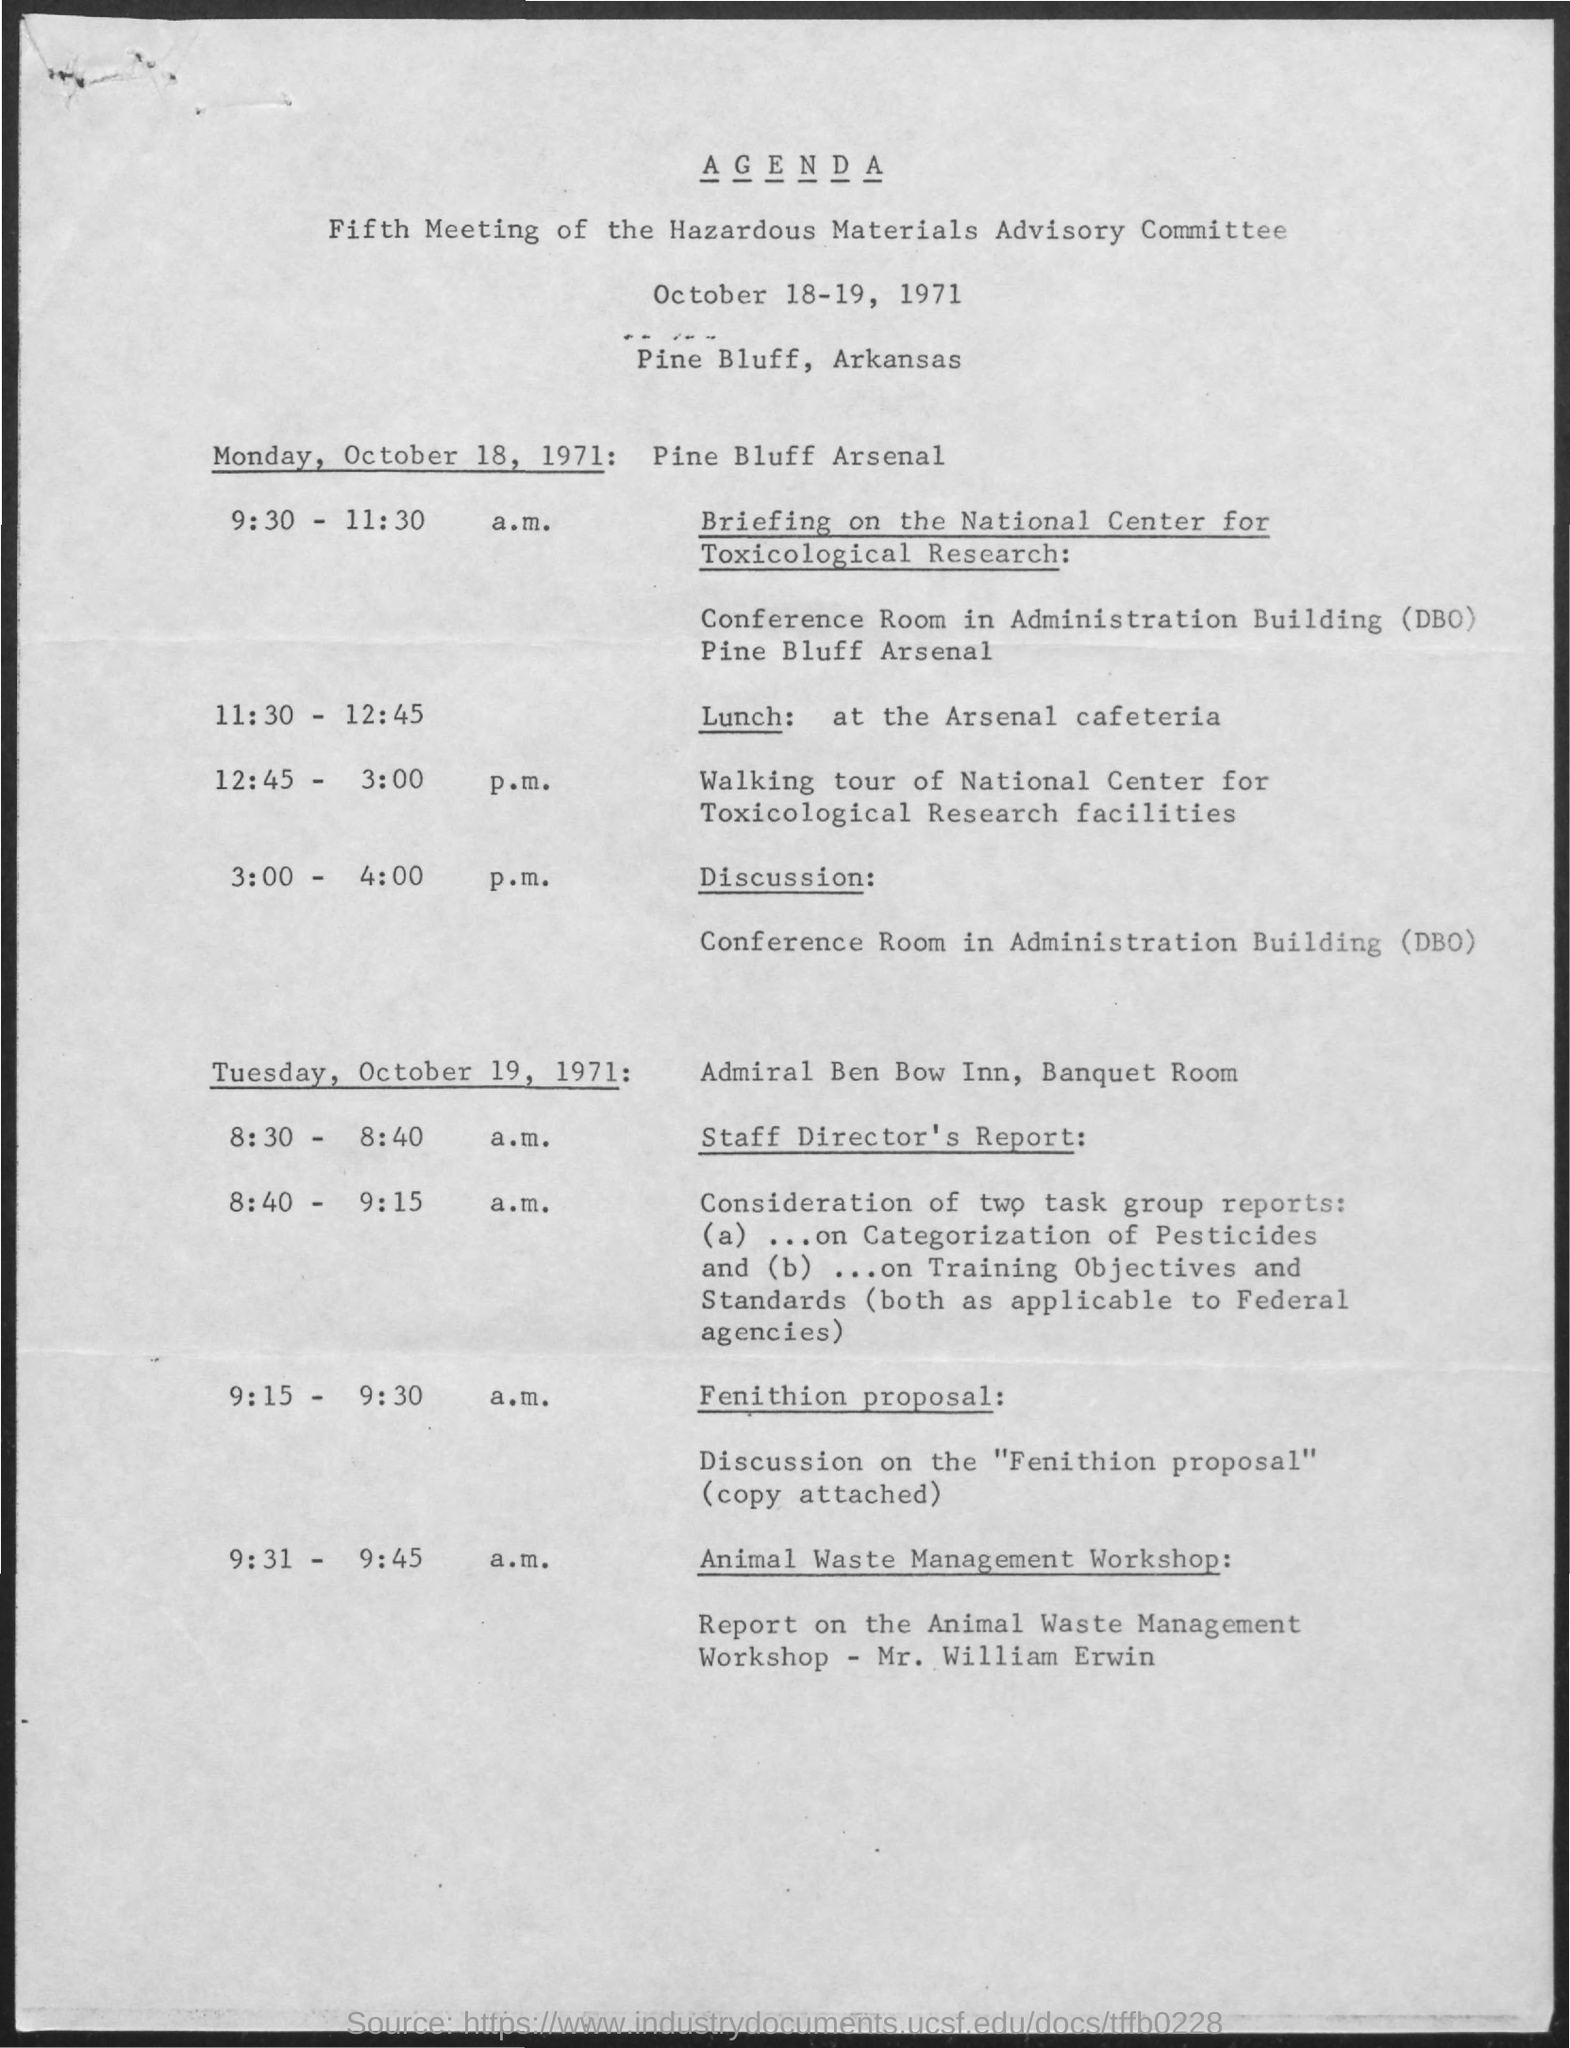Outline some significant characteristics in this image. I am eating lunch from 11:30 - 12:45. On October 19, 1971, the meeting was held at the Admiral Ben Bow Inn, Banquet Room. The lunch is held at the Arsenal Cafeteria. The event will take place in Pine Bluff, Arkansas. The committee meeting was held on October 18-19, 1971. 